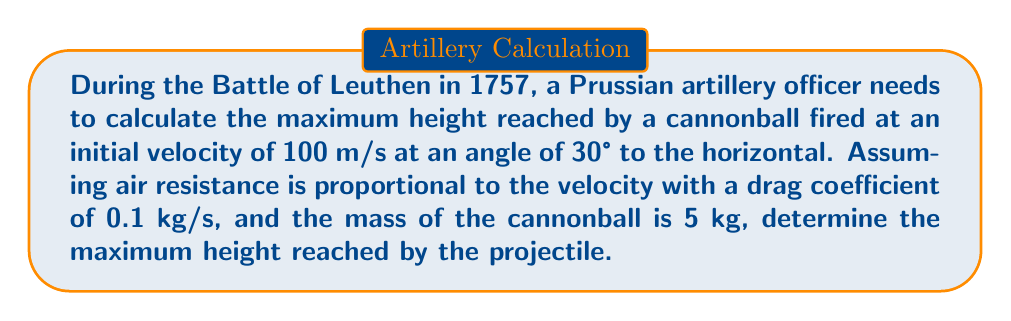Can you solve this math problem? To solve this problem, we need to use the first-order differential equations that describe the motion of a projectile with air resistance. Let's break it down step by step:

1) First, we need to set up our equations of motion. With air resistance proportional to velocity, we have:

   $$\frac{dx}{dt} = v_x$$
   $$\frac{dy}{dt} = v_y$$
   $$m\frac{dv_x}{dt} = -kv_x$$
   $$m\frac{dv_y}{dt} = -kv_y - mg$$

   where $k$ is the drag coefficient, $m$ is the mass, and $g$ is the acceleration due to gravity (9.8 m/s²).

2) We're interested in the maximum height, which occurs when $v_y = 0$. We don't need to solve for $x$ or $v_x$.

3) The initial conditions are:
   $v_{x0} = v_0 \cos \theta = 100 \cos 30° = 86.6$ m/s
   $v_{y0} = v_0 \sin \theta = 100 \sin 30° = 50$ m/s

4) From the equation for $v_y$, we can derive:

   $$\frac{dv_y}{dt} = -\frac{k}{m}v_y - g$$

5) This is a first-order linear differential equation. The solution is:

   $$v_y = \left(v_{y0} + \frac{mg}{k}\right)e^{-\frac{k}{m}t} - \frac{mg}{k}$$

6) To find the maximum height, we need to find when $v_y = 0$:

   $$0 = \left(v_{y0} + \frac{mg}{k}\right)e^{-\frac{k}{m}t} - \frac{mg}{k}$$

7) Solving for $t$:

   $$t = \frac{m}{k}\ln\left(1 + \frac{kv_{y0}}{mg}\right)$$

8) Now we can find $y$ by integrating $v_y$:

   $$y = \int_0^t v_y dt = \frac{m}{k}\left(v_{y0} + \frac{mg}{k}\right)\left(1 - e^{-\frac{k}{m}t}\right) - \frac{mg}{k}t$$

9) Substituting the value of $t$ from step 7 into this equation will give us the maximum height.

10) Plugging in our values:
    $m = 5$ kg, $k = 0.1$ kg/s, $v_{y0} = 50$ m/s, $g = 9.8$ m/s²

    $$t = \frac{5}{0.1}\ln\left(1 + \frac{0.1 \cdot 50}{5 \cdot 9.8}\right) = 22.96$$ seconds

    $$y_{max} = \frac{5}{0.1}\left(50 + \frac{5 \cdot 9.8}{0.1}\right)\left(1 - e^{-\frac{0.1}{5}22.96}\right) - \frac{5 \cdot 9.8}{0.1}22.96$$

11) Calculating this gives us the maximum height reached by the cannonball.
Answer: The maximum height reached by the cannonball is approximately 91.4 meters. 